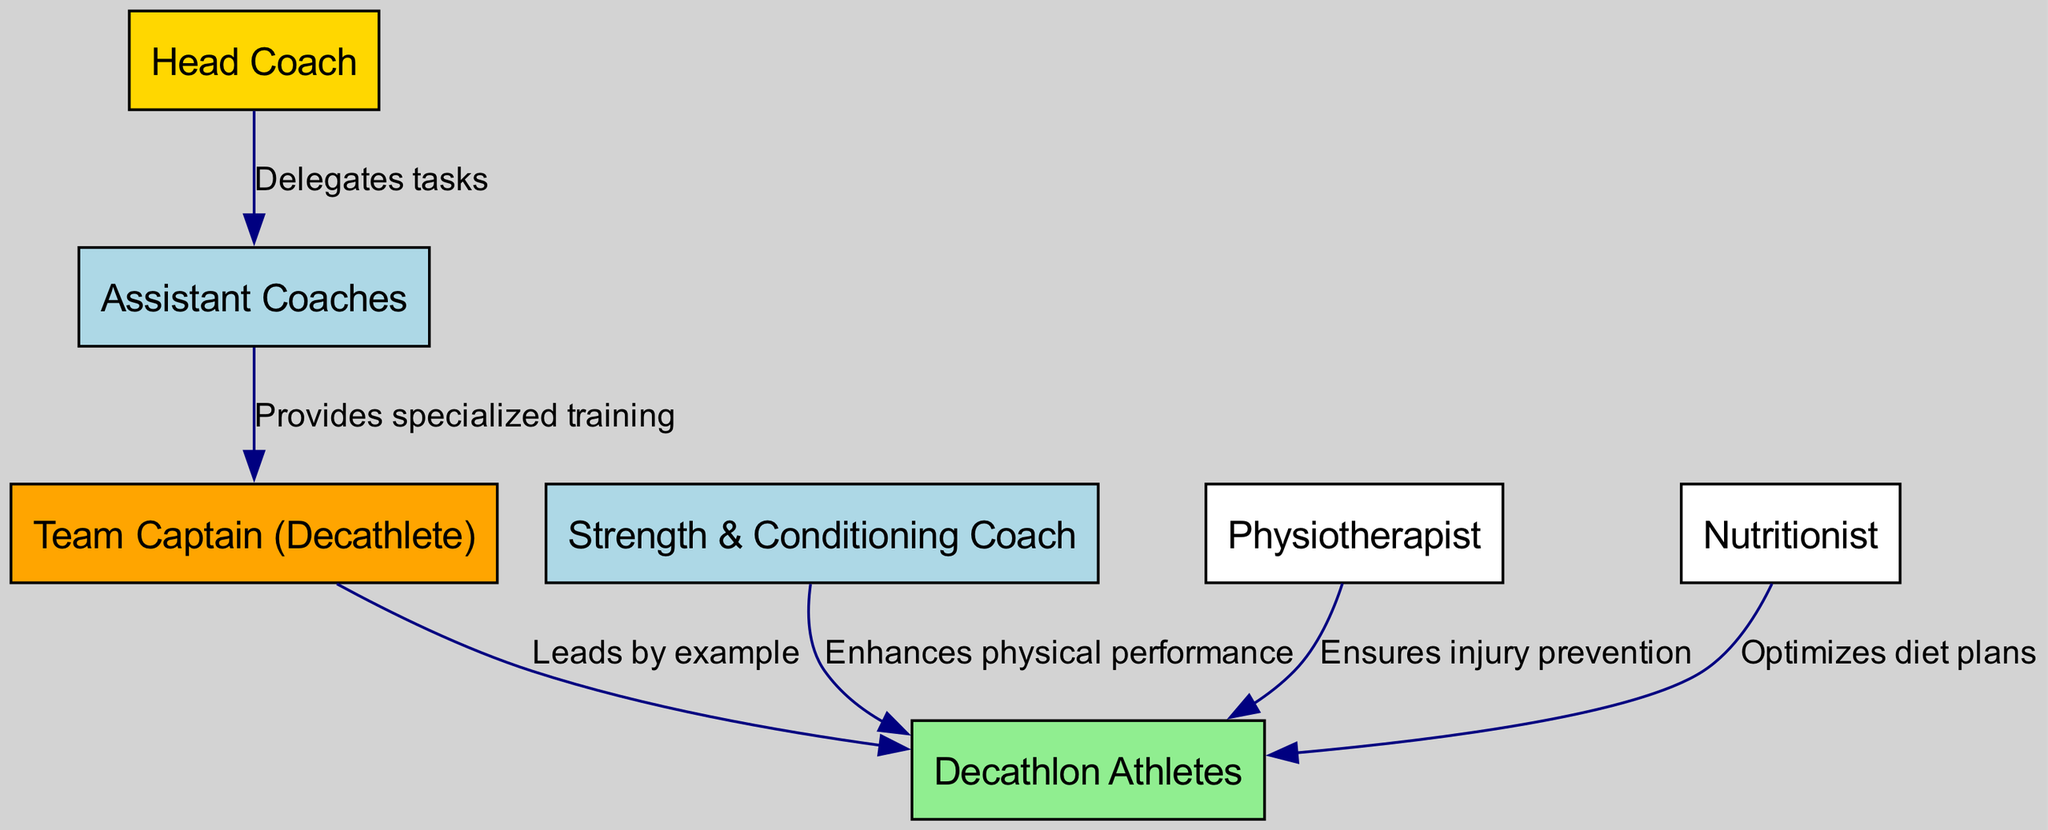What is the highest position in the leadership chain? The diagram shows the "Head Coach" as the top node, indicating the highest position in the leadership chain.
Answer: Head Coach How many coaches are involved in the leadership influence chain? The diagram lists three coaches: the "Head Coach," "Assistant Coaches," and "Strength & Conditioning Coach," totaling three.
Answer: Three What role does the Team Captain (Decathlete) play in the team dynamics? The arrow from the "Team Captain (Decathlete)" to "Decathlon Athletes" labeled "Leads by example" shows that the Team Captain has a leading role among the athletes.
Answer: Leads by example Which coach enhances the physical performance of the athletes? The edge from "Strength & Conditioning Coach" to "Decathlon Athletes" labeled "Enhances physical performance" specifically indicates that this coach is responsible for improving athletes' physical capabilities.
Answer: Strength & Conditioning Coach What task do Assistant Coaches have according to the diagram? The edge from the "Head Coach" to "Assistant Coaches" labeled "Delegates tasks" shows that the Head Coach assigns responsibilities to the Assistant Coaches.
Answer: Delegates tasks Who ensures injury prevention for the athletes? The diagram illustrates that the "Physiotherapist" has an influence on the "Decathlon Athletes," indicated by the edge labeled "Ensures injury prevention."
Answer: Physiotherapist What is the relationship between the Head Coach and Assistant Coaches? The arrow connecting "Head Coach" to "Assistant Coaches" with the label "Delegates tasks" establishes a hierarchical relationship where the Head Coach assigns tasks to the Assistant Coaches.
Answer: Delegates tasks Which member of the team optimizes diet plans? The diagram illustrates that the "Nutritionist" contributes to the well-being of "Decathlon Athletes" as shown by the edge labeled "Optimizes diet plans."
Answer: Nutritionist How many edges are present in the diagram? By counting the connections, there are six edges shown in the diagram that depict relationships among the nodes.
Answer: Six 